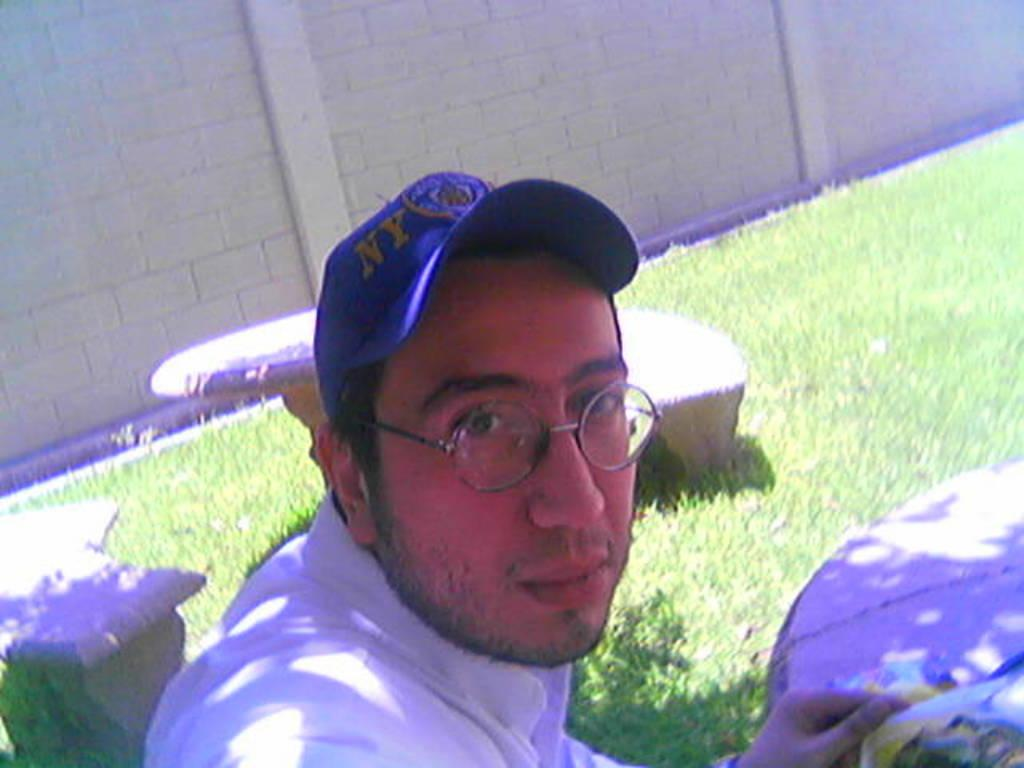Who is present in the image? There is a man in the image. What accessories is the man wearing? The man is wearing glasses and a cap. How many benches and tables are in the image? There are two benches and two tables in the image. What can be seen in the background of the image? There is a wall and grass in the background of the image. What page of the book is the man discussing with his friend in the image? There is no book or discussion present in the image; it only features a man wearing glasses and a cap, along with benches, tables, a wall, and grass in the background. 